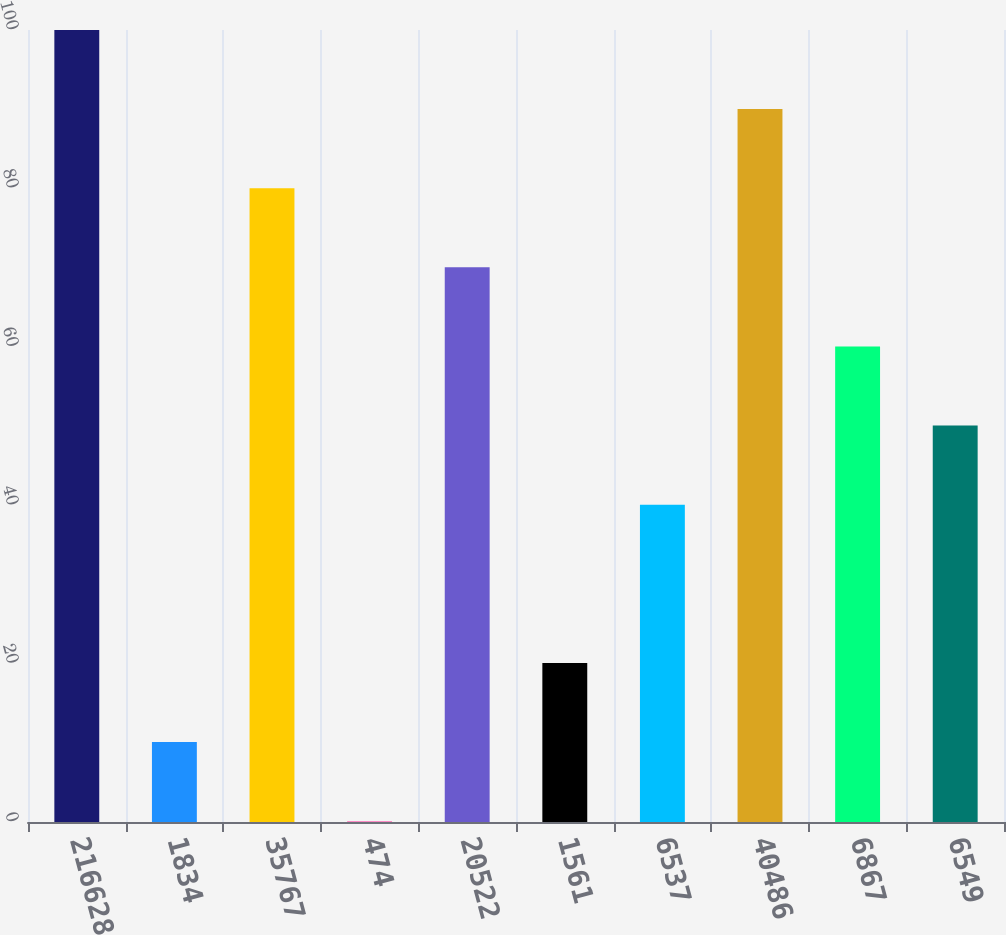<chart> <loc_0><loc_0><loc_500><loc_500><bar_chart><fcel>216628<fcel>1834<fcel>35767<fcel>474<fcel>20522<fcel>1561<fcel>6537<fcel>40486<fcel>6867<fcel>6549<nl><fcel>100<fcel>10.09<fcel>80.02<fcel>0.1<fcel>70.03<fcel>20.08<fcel>40.06<fcel>90.01<fcel>60.04<fcel>50.05<nl></chart> 